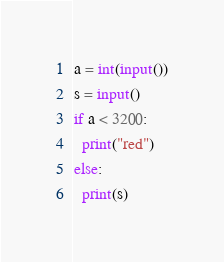Convert code to text. <code><loc_0><loc_0><loc_500><loc_500><_Python_>a = int(input())
s = input()
if a < 3200:
  print("red")
else:
  print(s)</code> 